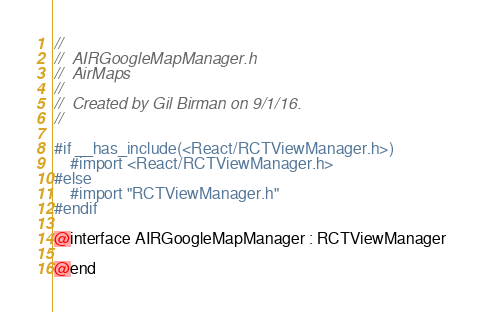<code> <loc_0><loc_0><loc_500><loc_500><_C_>//
//  AIRGoogleMapManager.h
//  AirMaps
//
//  Created by Gil Birman on 9/1/16.
//

#if __has_include(<React/RCTViewManager.h>)
    #import <React/RCTViewManager.h>
#else
    #import "RCTViewManager.h"
#endif

@interface AIRGoogleMapManager : RCTViewManager

@end
</code> 